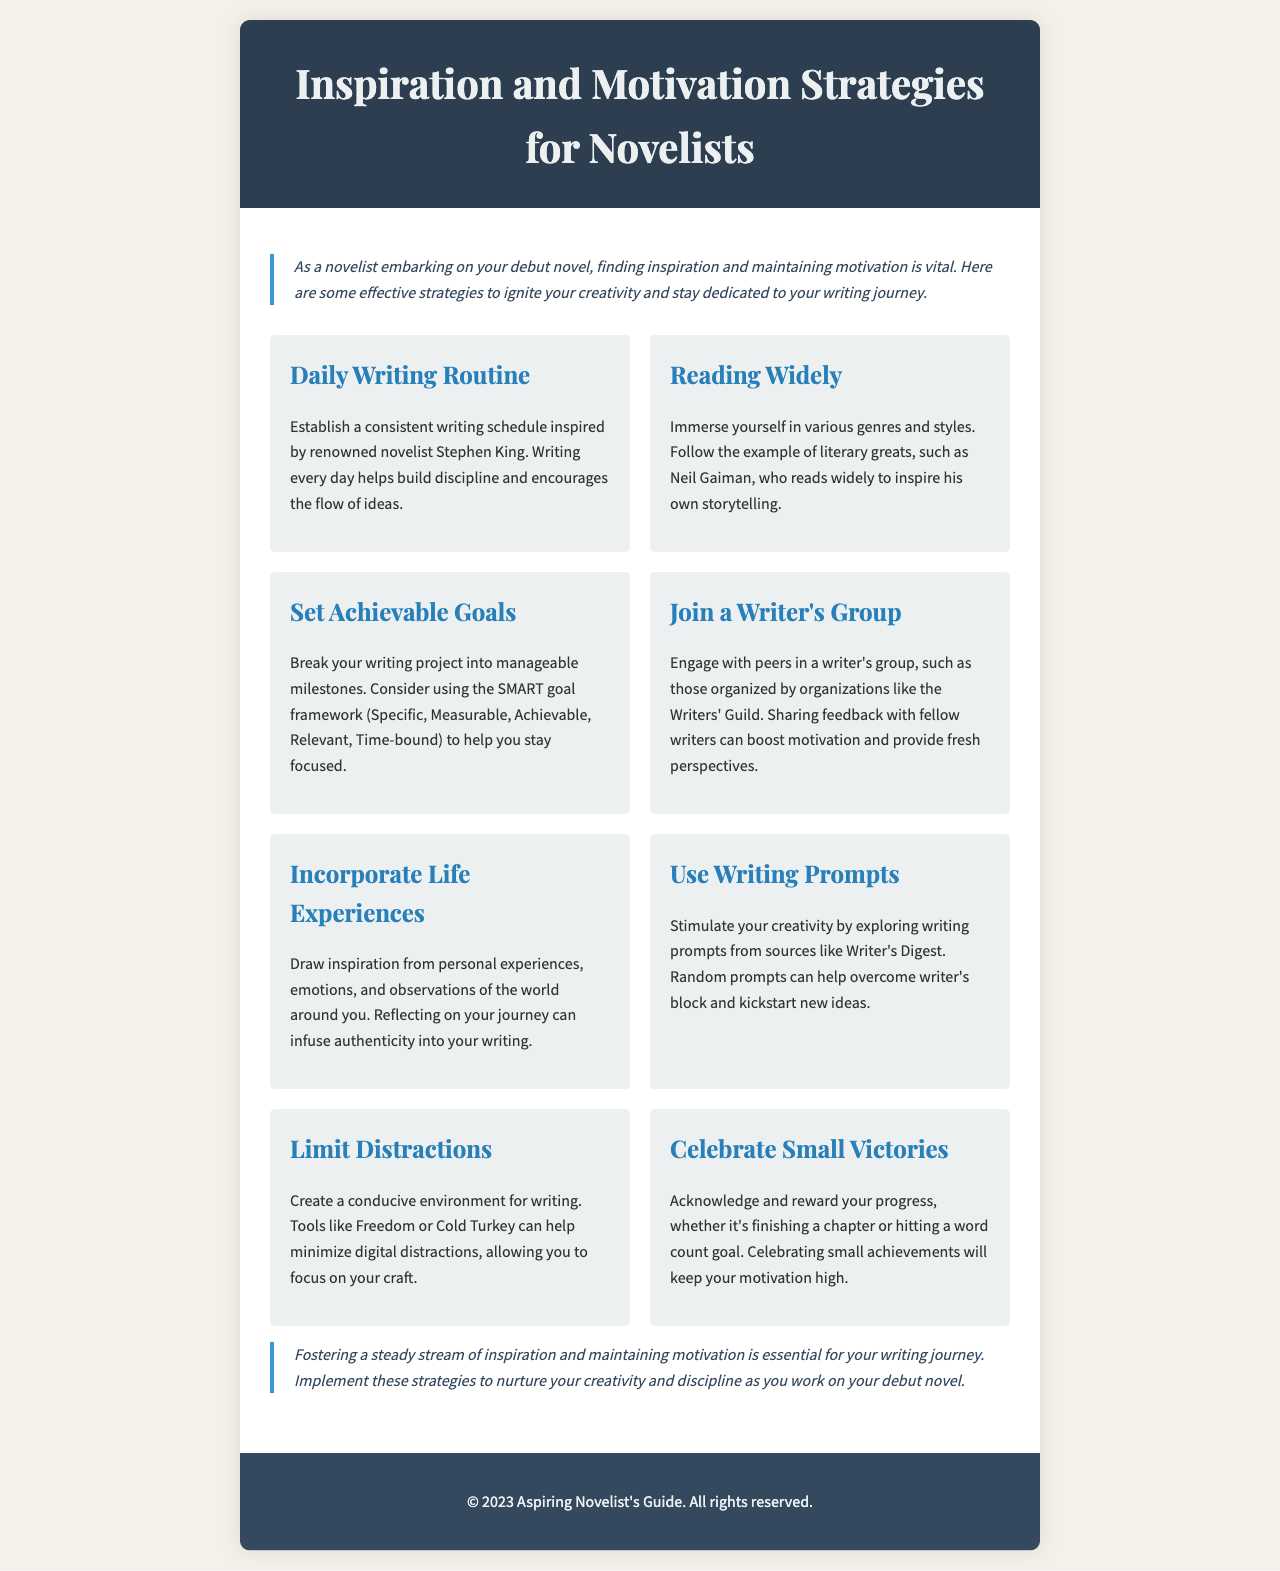What is the title of the brochure? The title appears prominently at the top of the document, establishing the main topic of discussion.
Answer: Inspiration and Motivation Strategies for Novelists Who is mentioned as a source of inspiration for a daily writing routine? The document references a well-known novelist to illustrate the importance of establishing a writing schedule.
Answer: Stephen King What framework is suggested for setting achievable goals? The document emphasizes using a specific framework to help writers set focused objectives.
Answer: SMART Which organization is suggested for joining a writer's group? The brochure recommends a specific organization where writers can find community and support.
Answer: Writers' Guild What is one method mentioned to limit distractions while writing? The document suggests using tools to create an environment conducive to writing.
Answer: Freedom What should writers celebrate to maintain motivation? The text states that acknowledging progress, regardless of size, is crucial for continued motivation.
Answer: Small Victories How many strategies are listed in the document? A count of the strategies presented in the content section provides insight into the document’s breadth.
Answer: Eight 